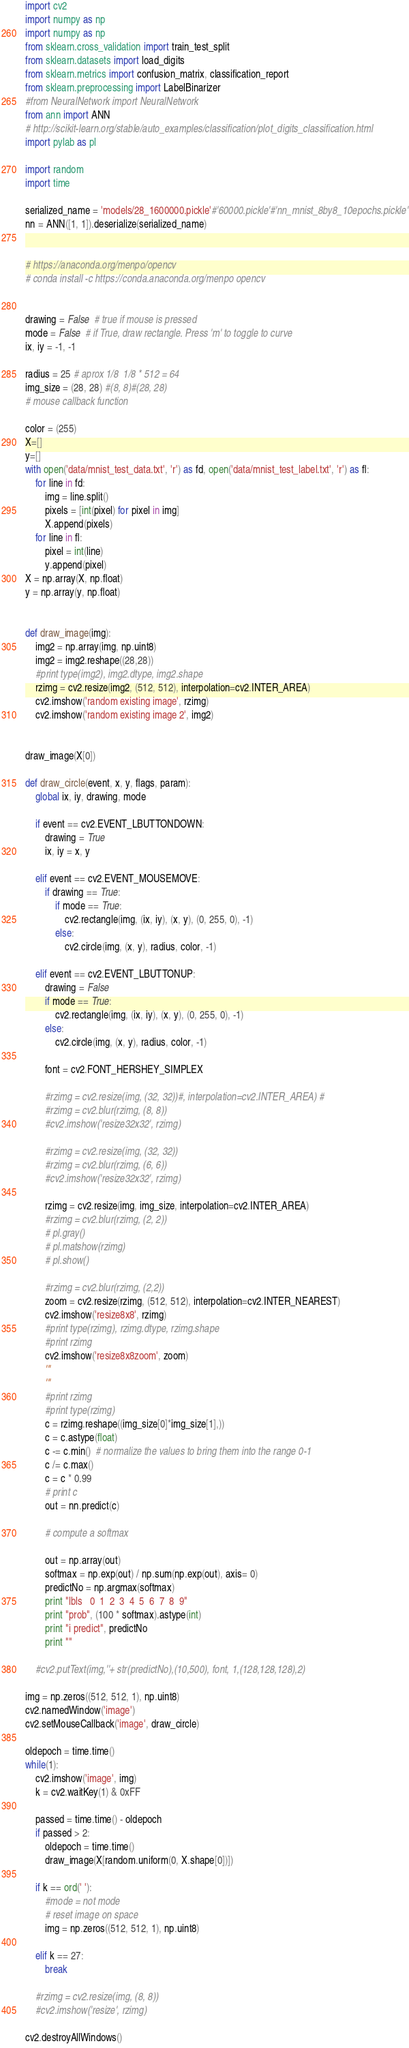<code> <loc_0><loc_0><loc_500><loc_500><_Python_>import cv2
import numpy as np
import numpy as np
from sklearn.cross_validation import train_test_split
from sklearn.datasets import load_digits
from sklearn.metrics import confusion_matrix, classification_report
from sklearn.preprocessing import LabelBinarizer
#from NeuralNetwork import NeuralNetwork
from ann import ANN
# http://scikit-learn.org/stable/auto_examples/classification/plot_digits_classification.html
import pylab as pl

import random
import time

serialized_name = 'models/28_1600000.pickle'#'60000.pickle'#'nn_mnist_8by8_10epochs.pickle'
nn = ANN([1, 1]).deserialize(serialized_name)


# https://anaconda.org/menpo/opencv
# conda install -c https://conda.anaconda.org/menpo opencv


drawing = False  # true if mouse is pressed
mode = False  # if True, draw rectangle. Press 'm' to toggle to curve
ix, iy = -1, -1

radius = 25 # aprox 1/8  1/8 * 512 = 64
img_size = (28, 28) #(8, 8)#(28, 28)
# mouse callback function

color = (255)
X=[]
y=[]
with open('data/mnist_test_data.txt', 'r') as fd, open('data/mnist_test_label.txt', 'r') as fl:
	for line in fd:
		img = line.split()
		pixels = [int(pixel) for pixel in img]
		X.append(pixels)
	for line in fl:
		pixel = int(line)
		y.append(pixel)
X = np.array(X, np.float)
y = np.array(y, np.float)


def draw_image(img):
	img2 = np.array(img, np.uint8)
	img2 = img2.reshape((28,28))
	#print type(img2), img2.dtype, img2.shape
	rzimg = cv2.resize(img2, (512, 512), interpolation=cv2.INTER_AREA)
	cv2.imshow('random existing image', rzimg)
	cv2.imshow('random existing image 2', img2)


draw_image(X[0])

def draw_circle(event, x, y, flags, param):
	global ix, iy, drawing, mode

	if event == cv2.EVENT_LBUTTONDOWN:
		drawing = True
		ix, iy = x, y

	elif event == cv2.EVENT_MOUSEMOVE:
		if drawing == True:
			if mode == True:
				cv2.rectangle(img, (ix, iy), (x, y), (0, 255, 0), -1)
			else:
				cv2.circle(img, (x, y), radius, color, -1)

	elif event == cv2.EVENT_LBUTTONUP:
		drawing = False
		if mode == True:
			cv2.rectangle(img, (ix, iy), (x, y), (0, 255, 0), -1)
		else:
			cv2.circle(img, (x, y), radius, color, -1)

		font = cv2.FONT_HERSHEY_SIMPLEX

		#rzimg = cv2.resize(img, (32, 32))#, interpolation=cv2.INTER_AREA) #
		#rzimg = cv2.blur(rzimg, (8, 8))
		#cv2.imshow('resize32x32', rzimg)

		#rzimg = cv2.resize(img, (32, 32))
		#rzimg = cv2.blur(rzimg, (6, 6))
		#cv2.imshow('resize32x32', rzimg)

		rzimg = cv2.resize(img, img_size, interpolation=cv2.INTER_AREA)
		#rzimg = cv2.blur(rzimg, (2, 2))
		# pl.gray()
		# pl.matshow(rzimg)
		# pl.show()

		#rzimg = cv2.blur(rzimg, (2,2))
		zoom = cv2.resize(rzimg, (512, 512), interpolation=cv2.INTER_NEAREST)
		cv2.imshow('resize8x8', rzimg)
		#print type(rzimg), rzimg.dtype, rzimg.shape
		#print rzimg
		cv2.imshow('resize8x8zoom', zoom)
		'''
		'''
		#print rzimg
		#print type(rzimg)
		c = rzimg.reshape((img_size[0]*img_size[1],))
		c = c.astype(float)
		c -= c.min()  # normalize the values to bring them into the range 0-1
		c /= c.max()
		c = c * 0.99
		# print c
		out = nn.predict(c)

		# compute a softmax

		out = np.array(out)
		softmax = np.exp(out) / np.sum(np.exp(out), axis= 0)
		predictNo = np.argmax(softmax)
		print "lbls   0  1  2  3  4  5  6  7  8  9"
		print "prob", (100 * softmax).astype(int)
		print "i predict", predictNo
		print ""

	#cv2.putText(img,''+ str(predictNo),(10,500), font, 1,(128,128,128),2)

img = np.zeros((512, 512, 1), np.uint8)
cv2.namedWindow('image')
cv2.setMouseCallback('image', draw_circle)

oldepoch = time.time()
while(1):
	cv2.imshow('image', img)
	k = cv2.waitKey(1) & 0xFF

	passed = time.time() - oldepoch
	if passed > 2:
		oldepoch = time.time()
		draw_image(X[random.uniform(0, X.shape[0])])

	if k == ord(' '):
		#mode = not mode
		# reset image on space
		img = np.zeros((512, 512, 1), np.uint8)
		
	elif k == 27:
		break

	#rzimg = cv2.resize(img, (8, 8))
	#cv2.imshow('resize', rzimg)

cv2.destroyAllWindows()
</code> 